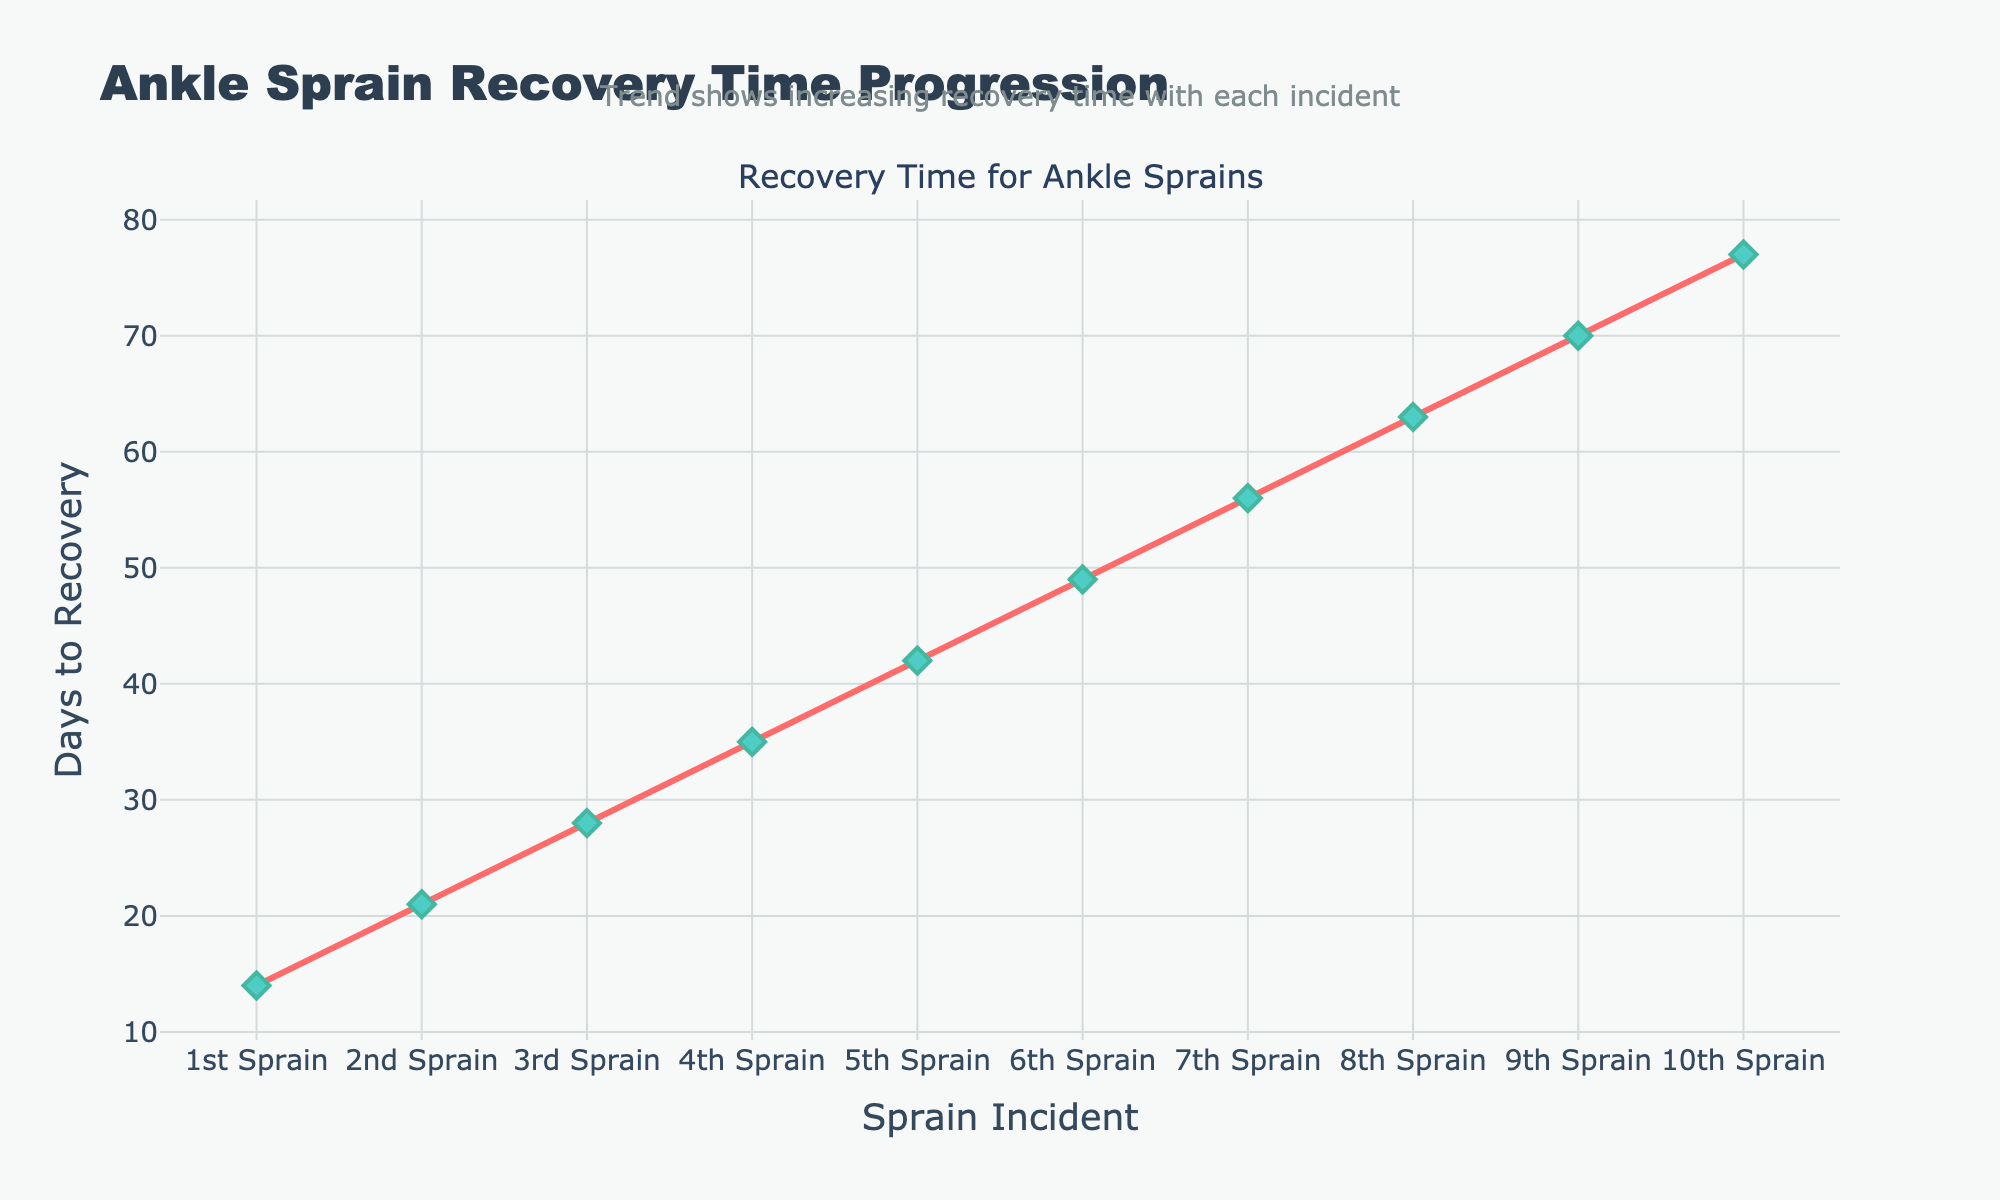What is the recovery time for the 5th sprain? To find the recovery time for the 5th sprain, look at the y-axis value corresponding to the "5th Sprain" on the x-axis. The y-coordinate indicates the number of days to recovery.
Answer: 42 days How has the recovery time changed from the 1st sprain to the 10th sprain? To find how the recovery time has changed, look at the y-axis values for both the 1st and 10th sprains and calculate the difference. The 1st sprain took 14 days and the 10th took 77 days. So, 77 - 14 = 63 days.
Answer: Increased by 63 days Which sprain had the longest recovery time? To determine the sprain with the longest recovery time, look for the highest point on the y-axis and identify the corresponding sprain on the x-axis. The highest point is at "10th Sprain."
Answer: 10th sprain Is the increase in recovery time consistent across all incidents? Examine the plot and see if the points form a straight line. Each sprain's recovery time increases by 7 days (e.g., 21 - 14 = 7, 28 - 21 = 7), indicating a consistent increment.
Answer: Yes What is the average recovery time for the first three sprains? Calculate the average by summing the recovery times for the first three sprains and dividing by three. (14 + 21 + 28) / 3 = 63 / 3 = 21 days.
Answer: 21 days Compare the recovery times between the 3rd and the 7th sprains. Identify the y-axis values for the 3rd and 7th sprains. The 3rd sprain is 28 days, and the 7th is 56 days. Now, compare: 56 is greater than 28.
Answer: The 7th sprain recovery time is longer What visual indication highlights the trend of increasing recovery time with each incident? The plot shows a line moving upward as you go from left to right. This upward slope visually indicates that the number of days to recovery increases with each successive sprain.
Answer: Upward slope What is the total recovery time for all ten sprains combined? Sum the recovery times for all ten sprains. 14 + 21 + 28 + 35 + 42 + 49 + 56 + 63 + 70 + 77 = 455 days.
Answer: 455 days Calculate the average recovery time over all incidents To find the average, sum all days to recovery and divide by the number of incidents. 455 days / 10 incidents = 45.5 days.
Answer: 45.5 days 